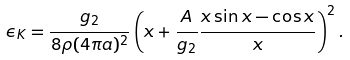Convert formula to latex. <formula><loc_0><loc_0><loc_500><loc_500>\epsilon _ { K } = \frac { g _ { 2 } } { 8 \rho ( 4 \pi a ) ^ { 2 } } \left ( x + \frac { A } { g _ { 2 } } \frac { x \sin x - \cos x } { x } \right ) ^ { 2 } .</formula> 